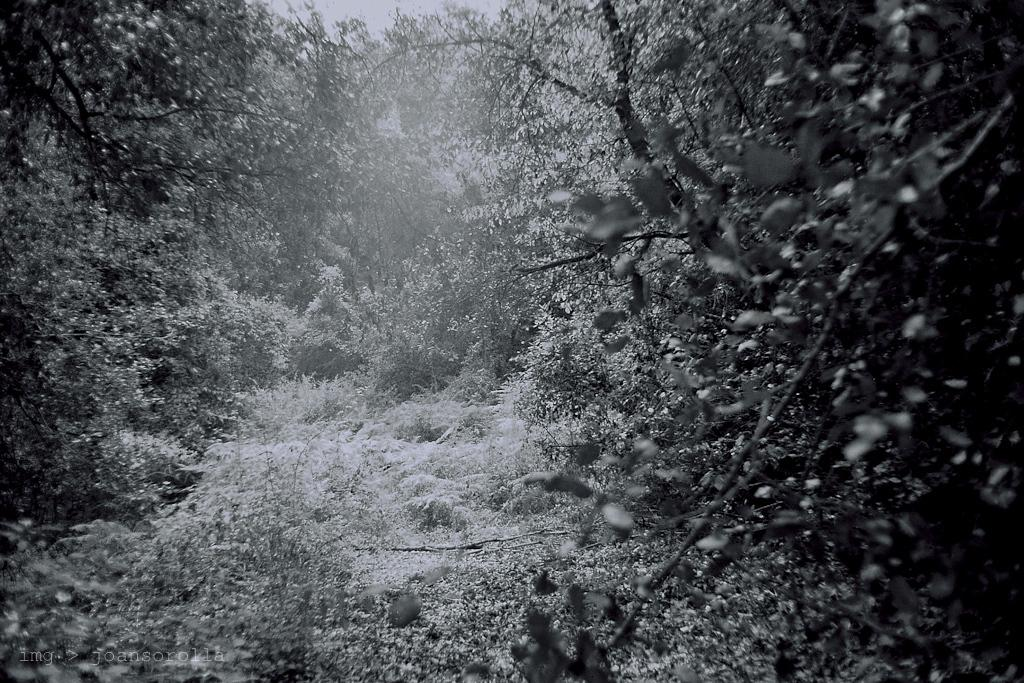What type of vegetation is in the center of the image? There are trees, grass, and plants in the center of the image. Can you describe the landscape in the center of the image? The landscape in the center of the image includes trees, grass, and plants. Is there a ray of light shining through the trees in the image? There is no mention of a ray of light in the provided facts, so we cannot determine if it is present in the image. 